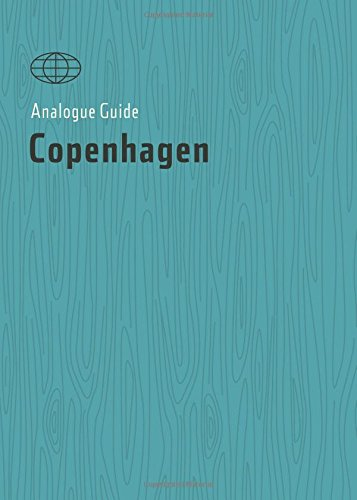Who is the author of this book? The author of this book, as clearly indicated on the cover, is Alana Stone. 